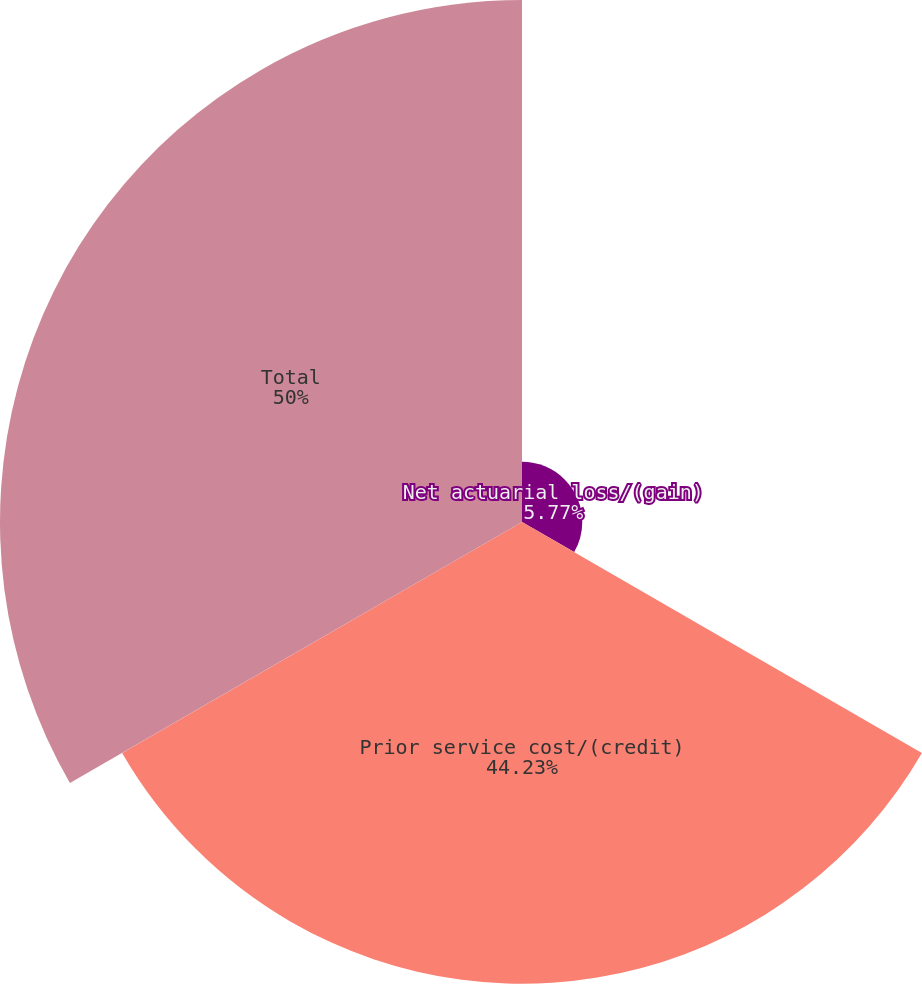<chart> <loc_0><loc_0><loc_500><loc_500><pie_chart><fcel>Net actuarial loss/(gain)<fcel>Prior service cost/(credit)<fcel>Total<nl><fcel>5.77%<fcel>44.23%<fcel>50.0%<nl></chart> 